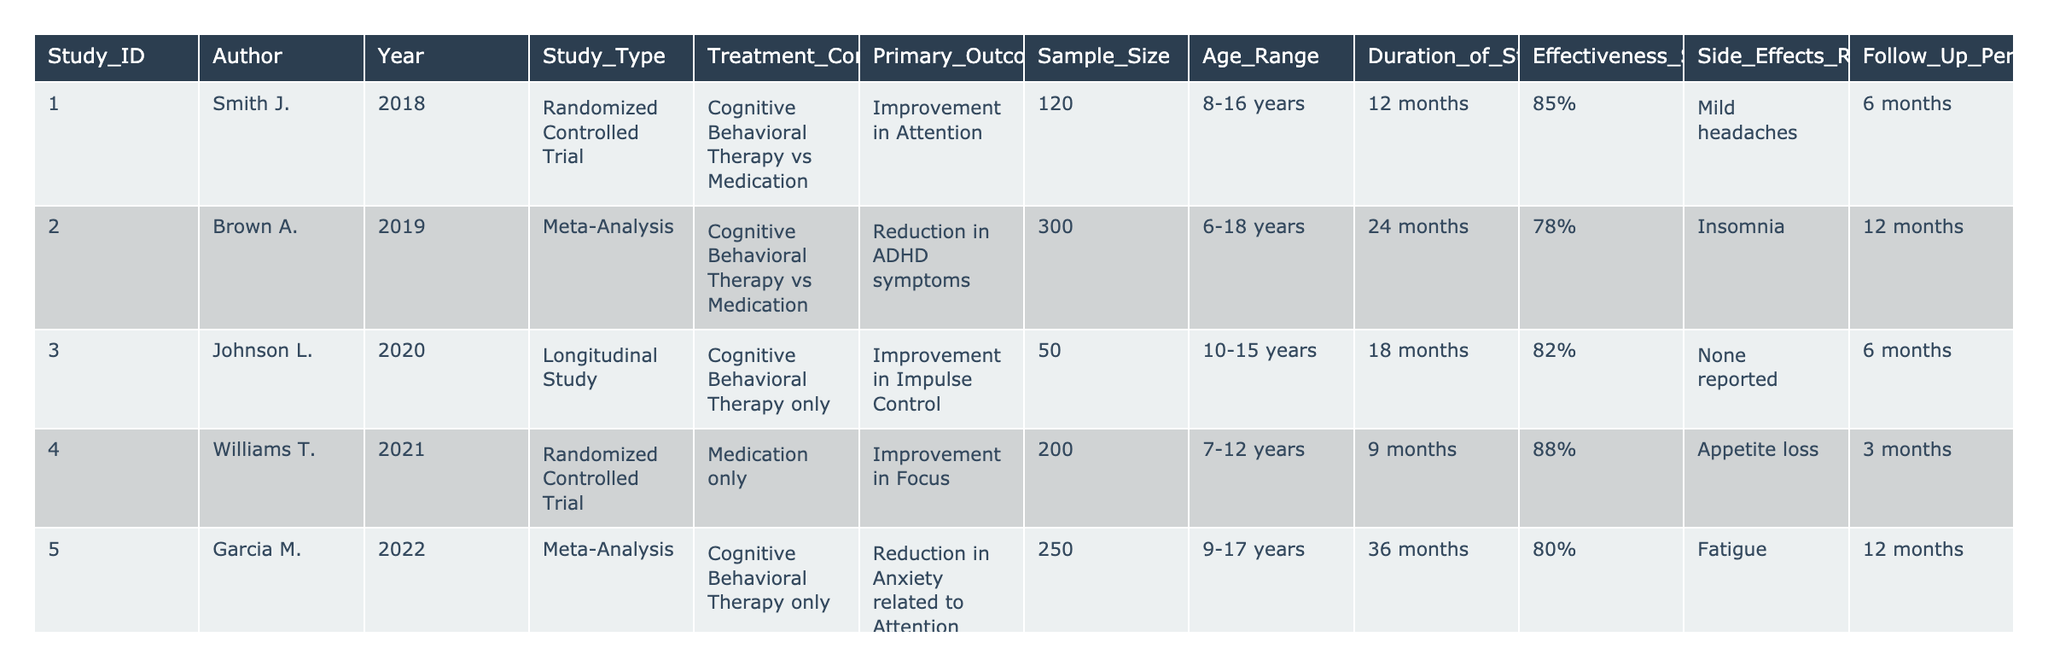What is the effectiveness score of the study by Smith J.? The effectiveness score for the study conducted by Smith J. in 2018 is listed in the table as 85%.
Answer: 85% Which study has the highest sample size? The study conducted by Brown A. in 2019 has the highest sample size of 300 participants.
Answer: 300 Is there any study that reported no side effects? The study by Johnson L. in 2020 reported no side effects according to the table.
Answer: Yes What is the average effectiveness score for studies comparing Cognitive Behavioral Therapy with Medication? The effectiveness scores are 85% (Smith J.), 78% (Brown A.), 90% (Martinez C.), and 75% (Davis R.), so the average is (85 + 78 + 90 + 75)/4 = 82%.
Answer: 82% Which treatment had a higher effectiveness score, Medication only or Cognitive Behavioral Therapy only? The effectiveness score for Medication only (88% by Williams T.) is higher than the effectiveness score for Cognitive Behavioral Therapy only (82% by Johnson L. and 80% by Garcia M.), therefore, the answer is Medication only.
Answer: Medication only How many studies had a follow-up period of 12 months? Three studies (Smith J., Brown A., and Garcia F.) listed in the table had a follow-up period of 12 months.
Answer: 3 What is the side effect reported in the study by Garcia M.? The study by Garcia M. in 2022 reported fatigue as a side effect.
Answer: Fatigue What is the difference in effectiveness scores between the study with the highest score and the study with the lowest score? The highest effectiveness score is 92% (Garcia F.) and the lowest is 75% (Davis R.), so the difference is 92 - 75 = 17%.
Answer: 17% Which author conducted research on the combined effect of Cognitive Behavioral Therapy and Medication? The study by Garcia F. in 2019 focused on the combined effect of Cognitive Behavioral Therapy plus Medication.
Answer: Garcia F How many studies were solely focused on Cognitive Behavioral Therapy? There are four studies (Johnson L., Garcia M., Lee H., and Garcia F.) focused solely on Cognitive Behavioral Therapy when including those combined with Medication or compared with a placebo.
Answer: 4 